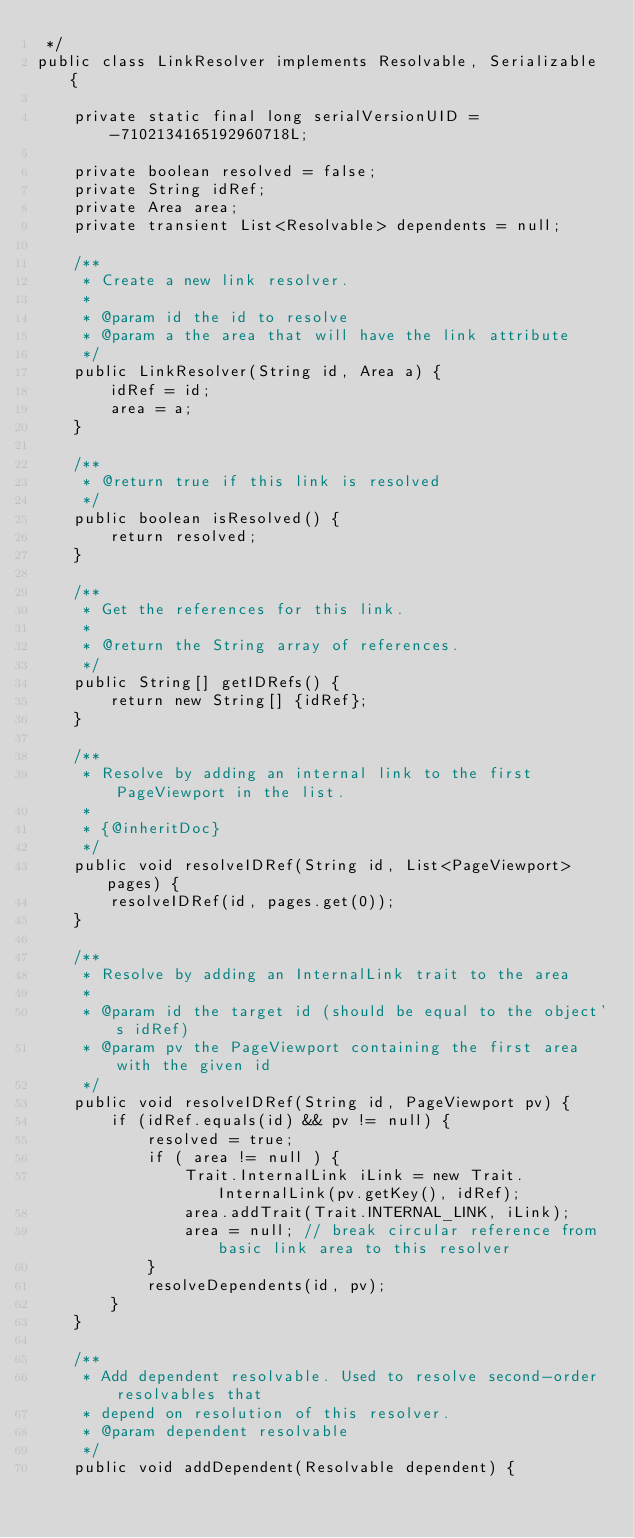<code> <loc_0><loc_0><loc_500><loc_500><_Java_> */
public class LinkResolver implements Resolvable, Serializable {

    private static final long serialVersionUID = -7102134165192960718L;

    private boolean resolved = false;
    private String idRef;
    private Area area;
    private transient List<Resolvable> dependents = null;

    /**
     * Create a new link resolver.
     *
     * @param id the id to resolve
     * @param a the area that will have the link attribute
     */
    public LinkResolver(String id, Area a) {
        idRef = id;
        area = a;
    }

    /**
     * @return true if this link is resolved
     */
    public boolean isResolved() {
        return resolved;
    }

    /**
     * Get the references for this link.
     *
     * @return the String array of references.
     */
    public String[] getIDRefs() {
        return new String[] {idRef};
    }

    /**
     * Resolve by adding an internal link to the first PageViewport in the list.
     *
     * {@inheritDoc}
     */
    public void resolveIDRef(String id, List<PageViewport> pages) {
        resolveIDRef(id, pages.get(0));
    }

    /**
     * Resolve by adding an InternalLink trait to the area
     *
     * @param id the target id (should be equal to the object's idRef)
     * @param pv the PageViewport containing the first area with the given id
     */
    public void resolveIDRef(String id, PageViewport pv) {
        if (idRef.equals(id) && pv != null) {
            resolved = true;
            if ( area != null ) {
                Trait.InternalLink iLink = new Trait.InternalLink(pv.getKey(), idRef);
                area.addTrait(Trait.INTERNAL_LINK, iLink);
                area = null; // break circular reference from basic link area to this resolver
            }
            resolveDependents(id, pv);
        }
    }

    /**
     * Add dependent resolvable. Used to resolve second-order resolvables that
     * depend on resolution of this resolver.
     * @param dependent resolvable
     */
    public void addDependent(Resolvable dependent) {</code> 